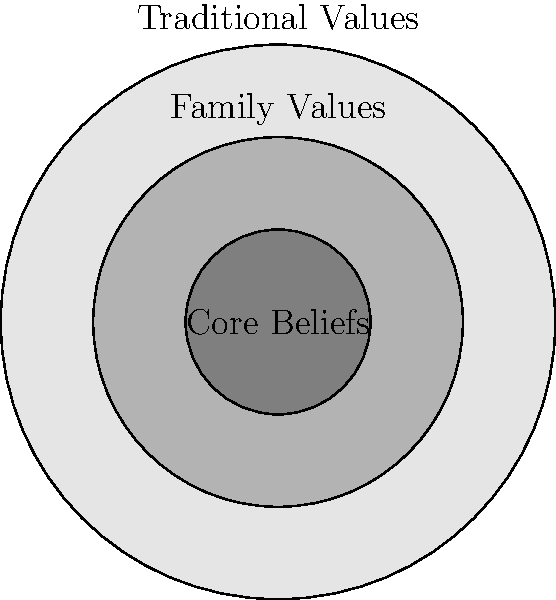In the diagram above, three concentric circles represent the preservation of cultural values in a traditional society. The outermost circle represents "Traditional Values," the middle circle represents "Family Values," and the innermost circle represents "Core Beliefs." If a new progressive children's book challenges some traditional values but doesn't affect family values or core beliefs, which set(s) would be impacted? To solve this problem, we need to understand the nested structure of the sets and how they relate to each other:

1. The outermost circle (Traditional Values) encompasses all other circles.
2. The middle circle (Family Values) is a subset of Traditional Values.
3. The innermost circle (Core Beliefs) is a subset of both Family Values and Traditional Values.

Given that the progressive children's book challenges some traditional values:

1. It will affect the outermost circle (Traditional Values).
2. It does not affect Family Values or Core Beliefs, so the middle and inner circles remain unchanged.

Therefore, only the set represented by the outermost circle (Traditional Values) would be impacted by the introduction of this progressive children's book.

This question highlights the importance of preserving core cultural values while acknowledging that some traditional values may be challenged by modern influences.
Answer: Traditional Values 